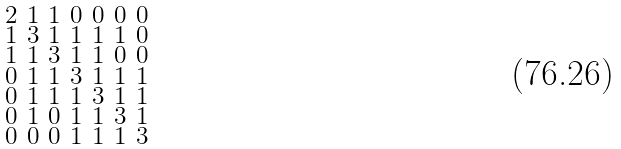<formula> <loc_0><loc_0><loc_500><loc_500>\begin{smallmatrix} 2 & 1 & 1 & 0 & 0 & 0 & 0 \\ 1 & 3 & 1 & 1 & 1 & 1 & 0 \\ 1 & 1 & 3 & 1 & 1 & 0 & 0 \\ 0 & 1 & 1 & 3 & 1 & 1 & 1 \\ 0 & 1 & 1 & 1 & 3 & 1 & 1 \\ 0 & 1 & 0 & 1 & 1 & 3 & 1 \\ 0 & 0 & 0 & 1 & 1 & 1 & 3 \end{smallmatrix}</formula> 